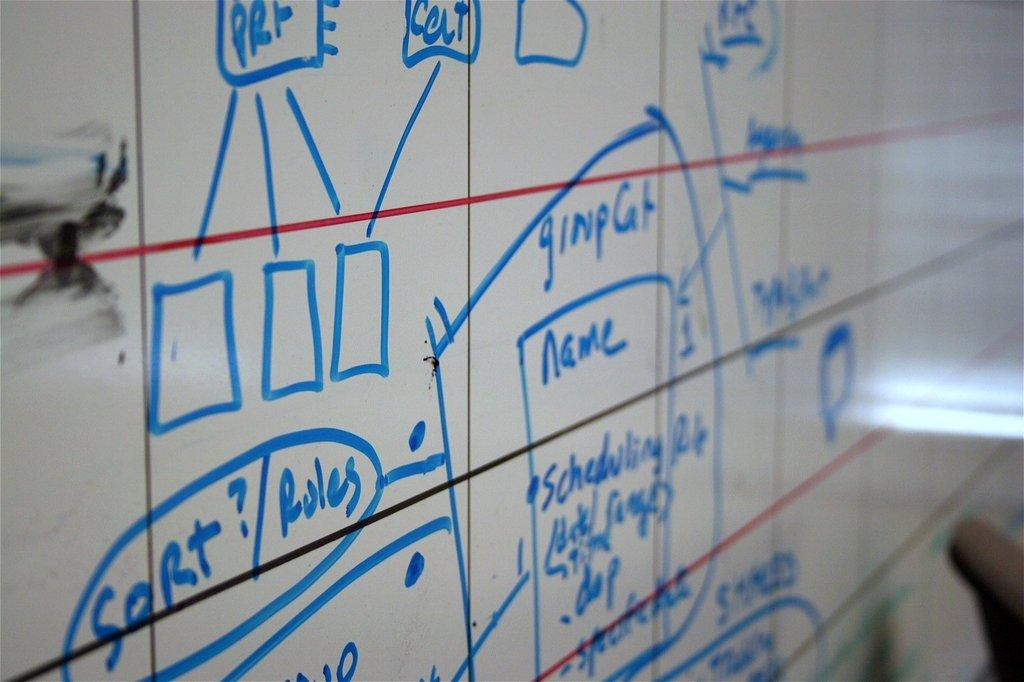<image>
Give a short and clear explanation of the subsequent image. A white board with blue writing and the word Rules visible. 